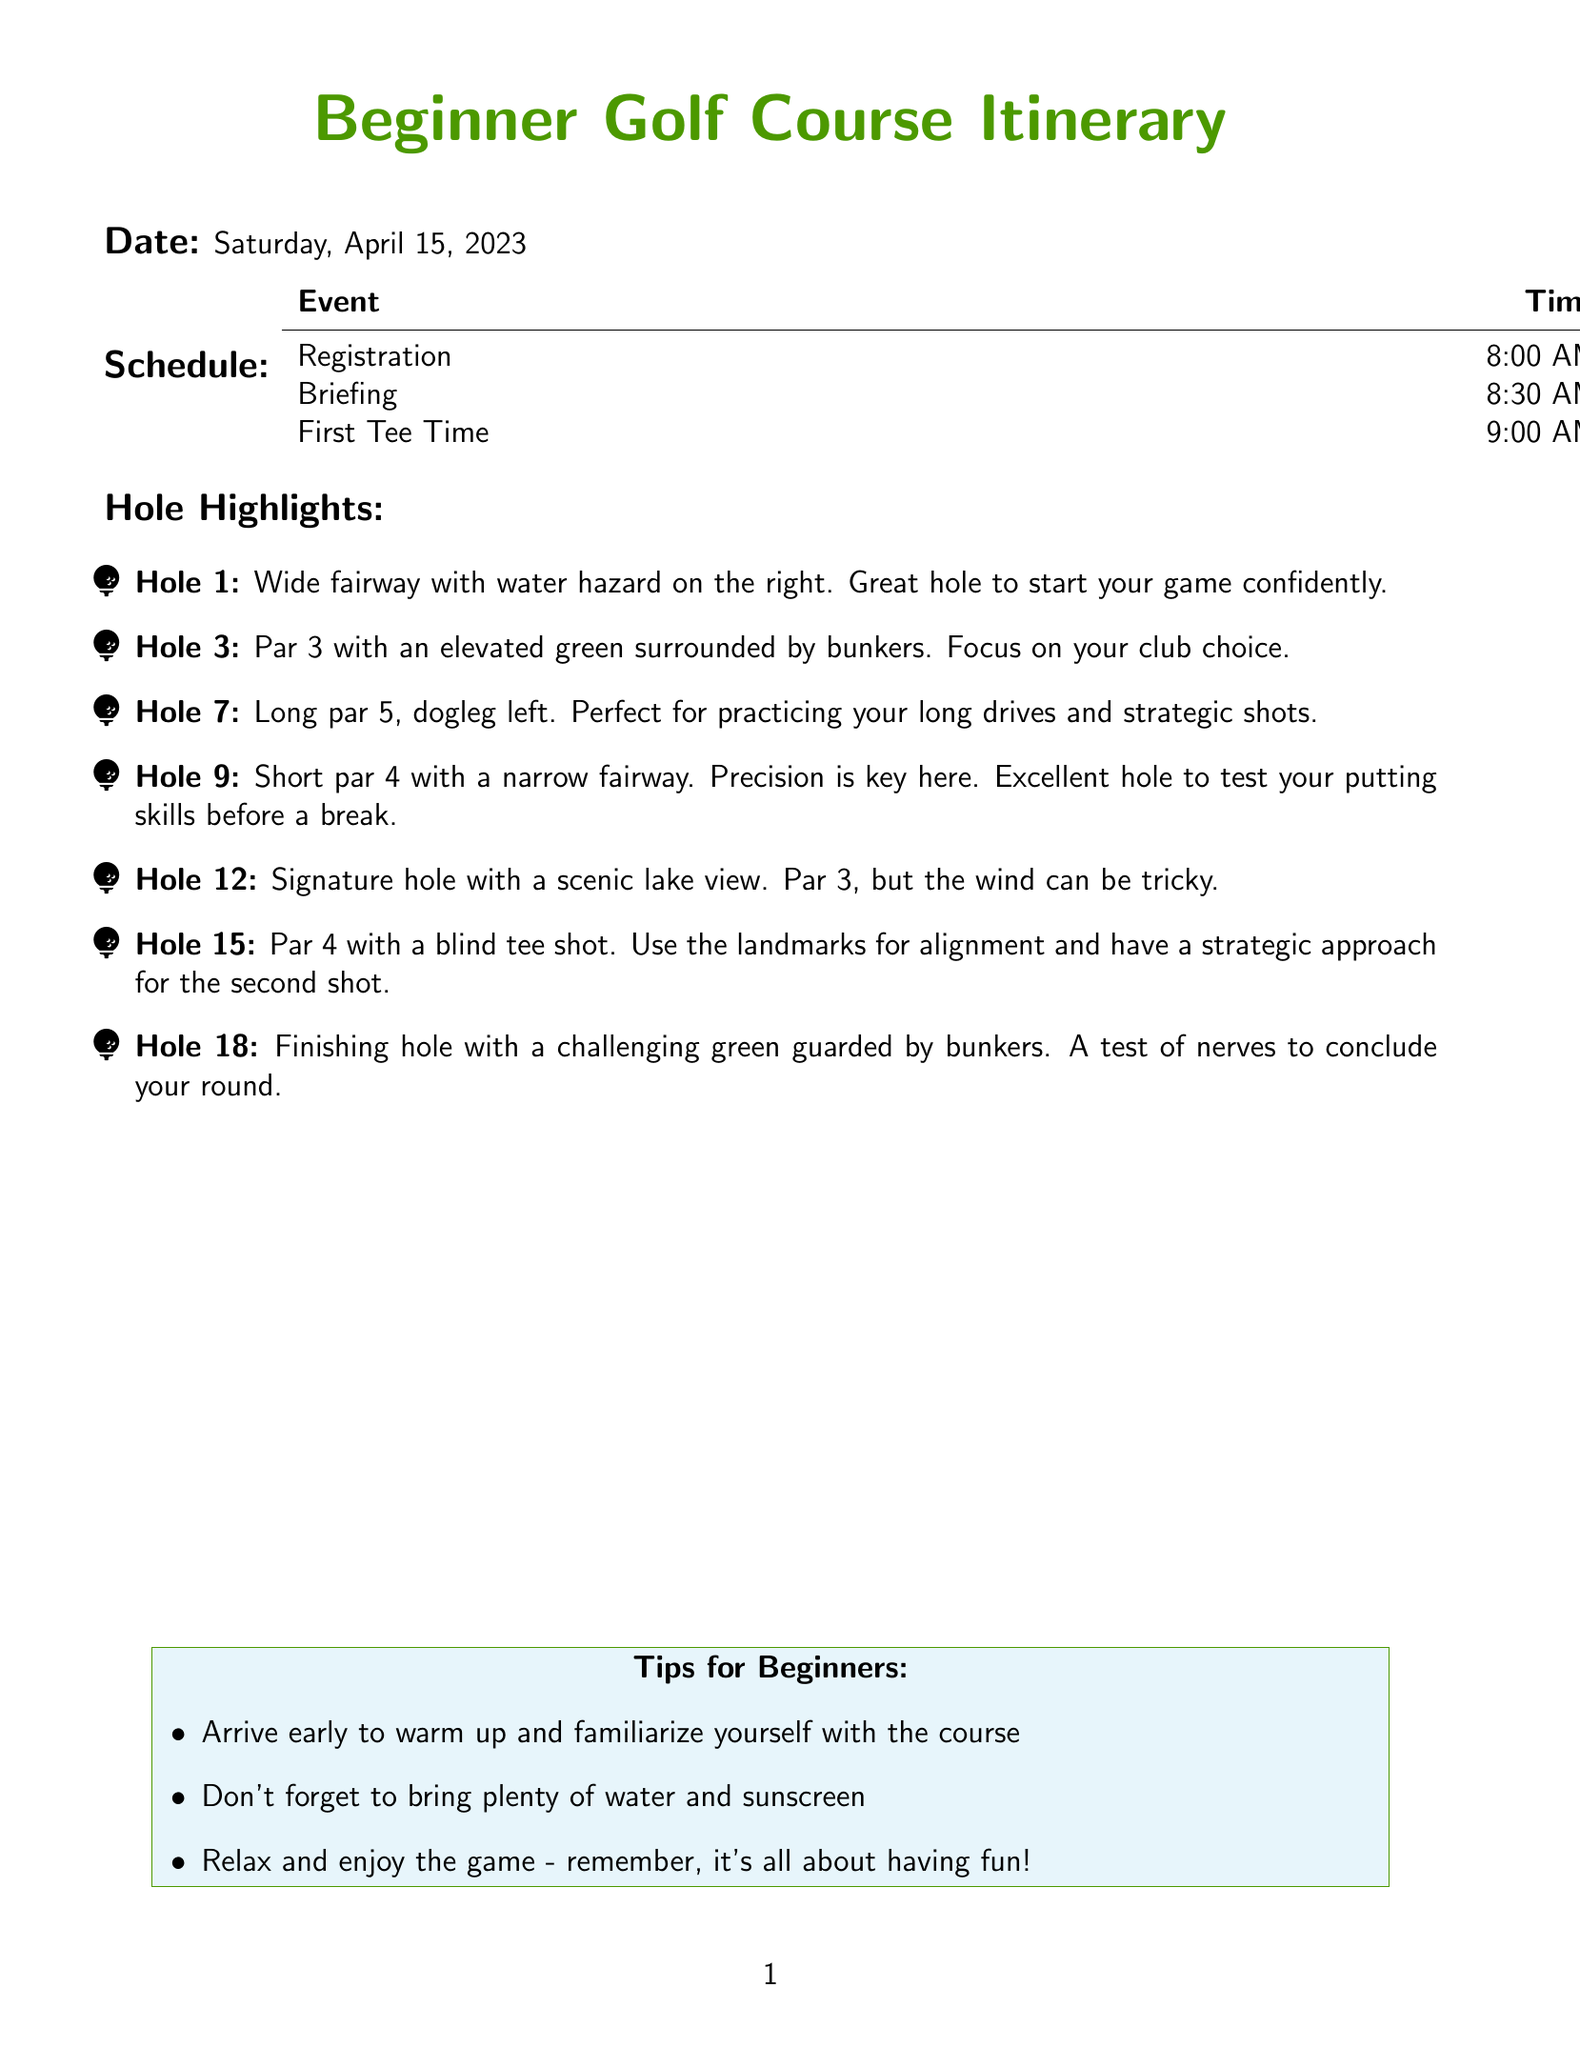What time does registration start? Registration is scheduled for 8:00 AM as mentioned in the schedule section of the document.
Answer: 8:00 AM What is the first event on the schedule? The first event listed in the schedule is registration, occurring at 8:00 AM.
Answer: Registration Which hole has a water hazard on the right? Hole 1 features a wide fairway with a water hazard on the right, as highlighted in the hole description.
Answer: Hole 1 How many holes are highlighted in the document? The document lists a total of seven holes in the hole highlights section.
Answer: Seven What is a key aspect of Hole 9? Hole 9 is described as a short par 4, where precision is key, indicating its difficulty and focus on accuracy.
Answer: Precision What type of hole is Hole 12? Hole 12 is identified as a par 3, marked as the signature hole with a scenic view.
Answer: Par 3 What time is the first tee time? The first tee time indicated in the schedule is at 9:00 AM.
Answer: 9:00 AM What tip is given for beginners regarding arrival? The tip for beginners suggests to "arrive early to warm up and familiarize yourself with the course."
Answer: Arrive early 